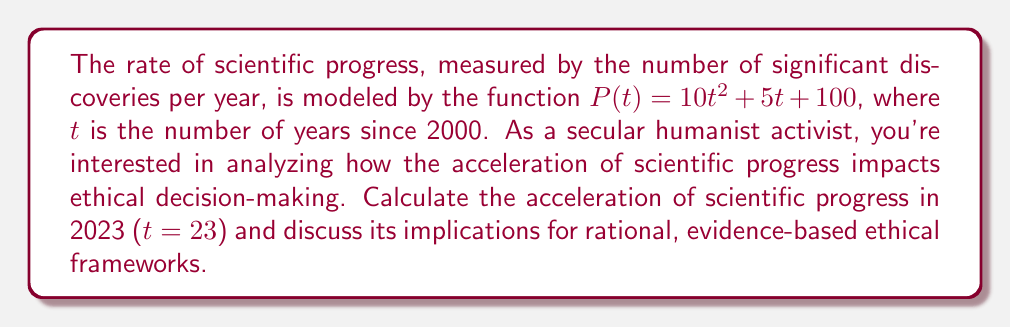Could you help me with this problem? To find the acceleration of scientific progress, we need to calculate the second derivative of the given function $P(t)$.

Step 1: Find the first derivative (velocity of progress)
$$P'(t) = \frac{d}{dt}(10t^2 + 5t + 100) = 20t + 5$$

Step 2: Find the second derivative (acceleration of progress)
$$P''(t) = \frac{d}{dt}(20t + 5) = 20$$

Step 3: The acceleration is constant at 20 discoveries per year^2, regardless of the value of t. This means the rate of scientific progress is increasing at a constant rate.

Step 4: To find the acceleration in 2023, we simply use the constant value:
$$P''(23) = 20$$

Implications for rational, evidence-based ethical frameworks:
1. The constant acceleration suggests a predictable increase in scientific knowledge, allowing for more informed ethical decision-making.
2. Rapid progress may challenge existing ethical frameworks, requiring frequent reassessment of moral principles based on new scientific insights.
3. The acceleration emphasizes the need for flexible, adaptable ethical systems that can incorporate new scientific discoveries.
4. It highlights the importance of evidence-based approaches to ethics, aligning with secular humanist principles.
5. The constant acceleration underscores the need for ongoing ethical education and discourse to keep pace with scientific advancements.
Answer: 20 discoveries/year^2 